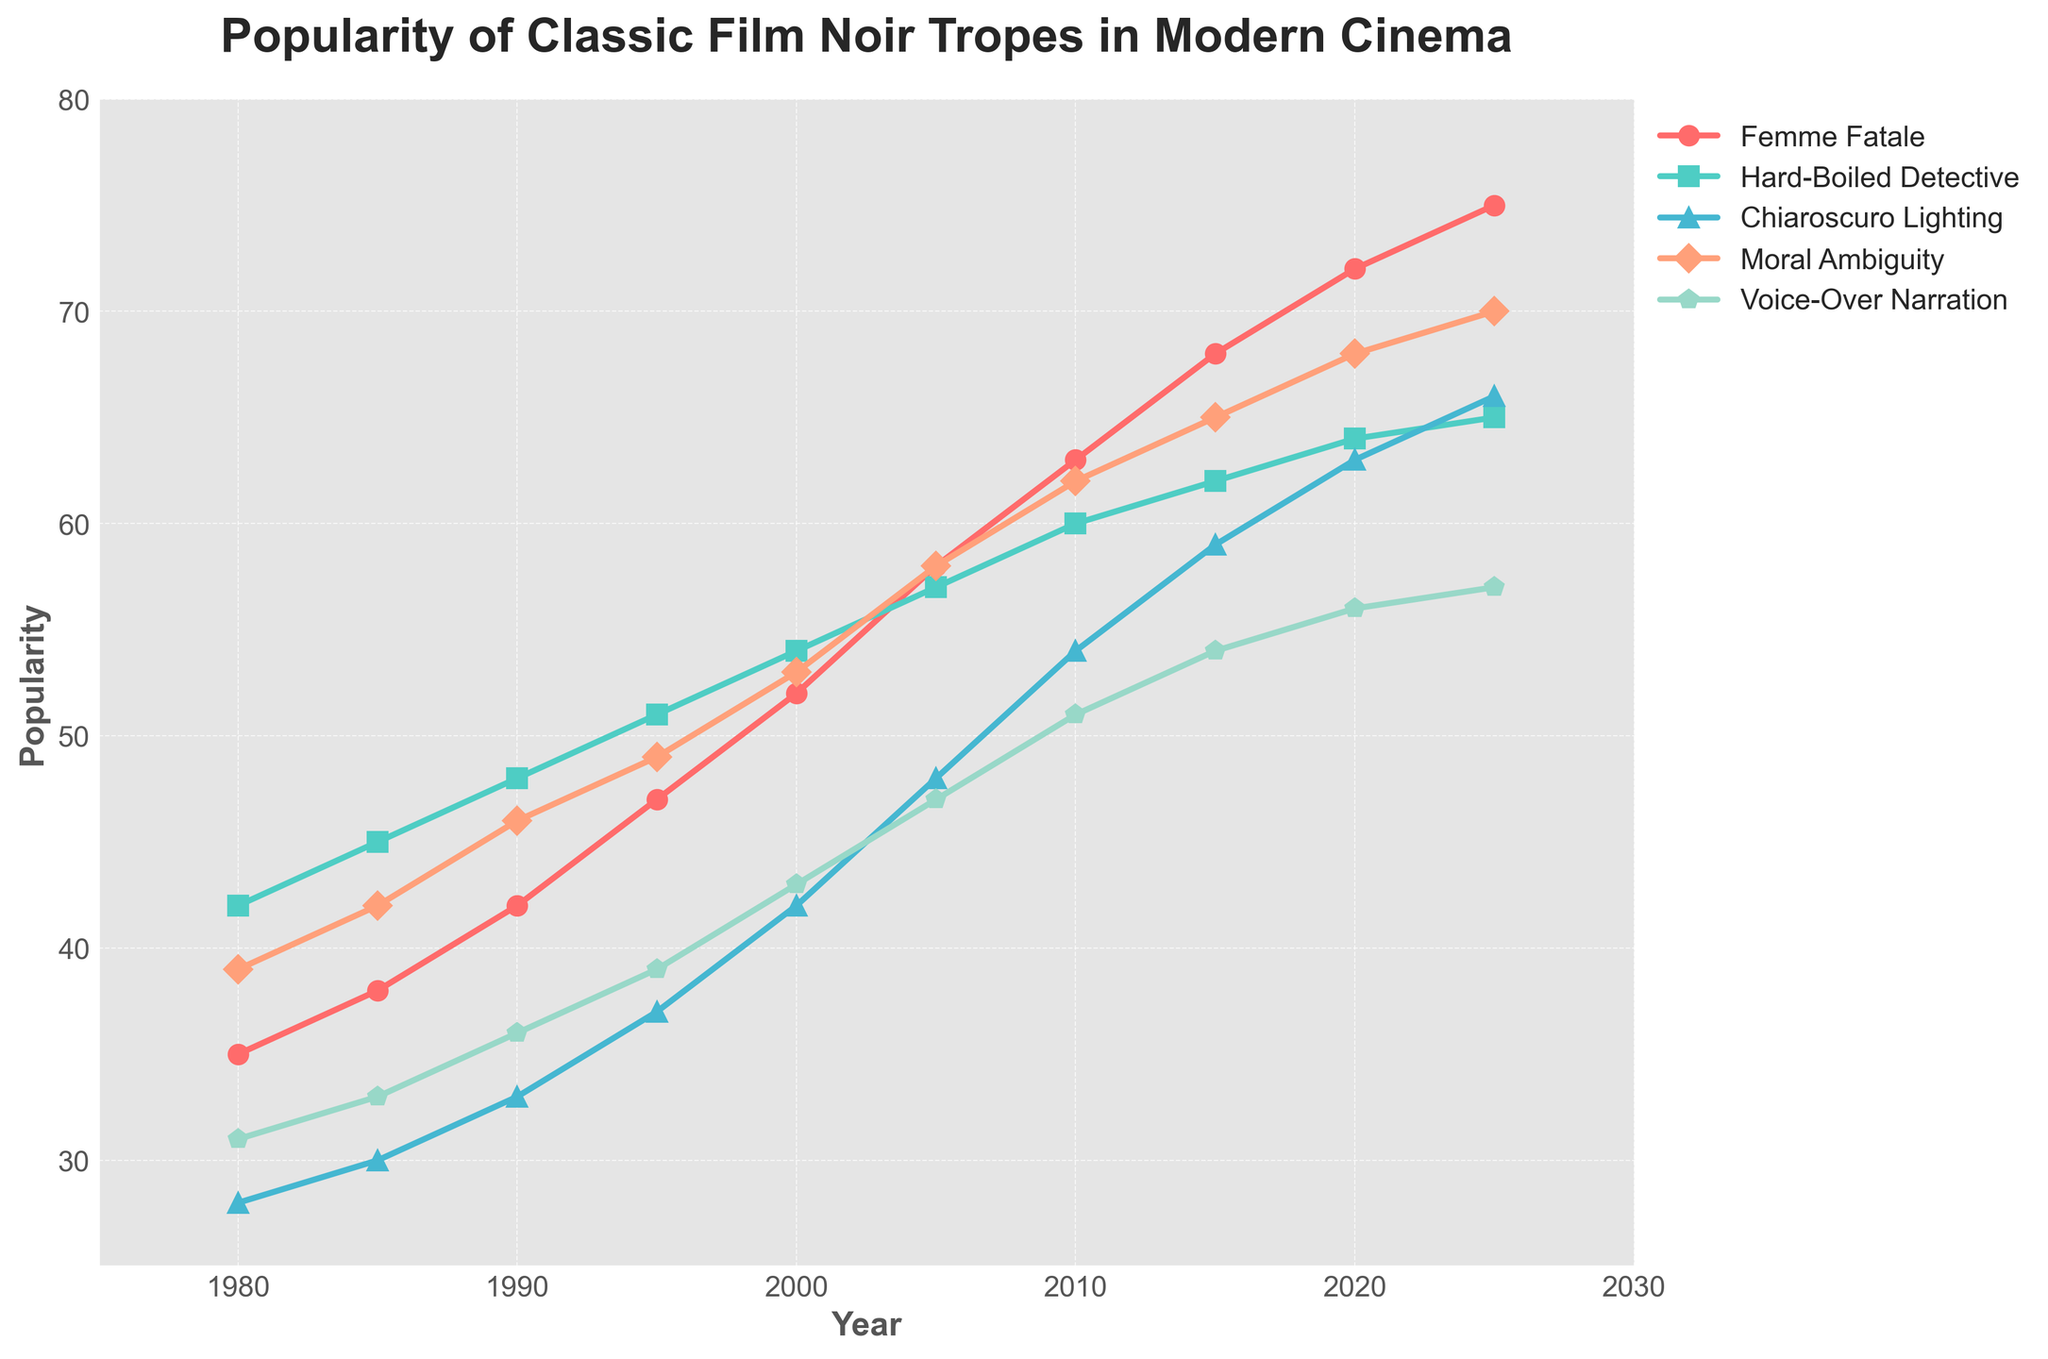What year did 'Femme Fatale' first surpass 50 in popularity? First, locate the line for 'Femme Fatale' (red) and follow it to see when it crosses the 50 mark. The plot shows it surpasses 50 in the year 2000.
Answer: 2000 Which trope reached 70 in popularity first? Look for the lines in the plot reaching 70. 'Moral Ambiguity' (orange) is the first to cross this mark in 2025.
Answer: Moral Ambiguity What is the difference in popularity between 'Hard-Boiled Detective' and 'Voice-Over Narration' in 2010? Locate the data points for 'Hard-Boiled Detective' (green) and 'Voice-Over Narration' (light blue) in 2010, which are 60 and 51 respectively. Subtract 51 from 60 to find the difference.
Answer: 9 Which trope shows the fastest increase in popularity from 1980 to 2025? Examine the slope of each line from 1980 to 2025. The steepest upward slope represents the fastest increase. 'Femme Fatale' (red) exhibits the most significant growth, going from 35 to 75.
Answer: Femme Fatale Which color represents 'Chiaroscuro Lighting'? Identify the line associated with 'Chiaroscuro Lighting' in the plot. This line is blue.
Answer: Blue In 1990, which trope was least popular, and what was its popularity score? Check the values for each trope in 1990. 'Chiaroscuro Lighting' (blue) has the lowest popularity score of 33.
Answer: Chiaroscuro Lighting, 33 What is the average popularity of 'Moral Ambiguity' over the entire time period? Sum all values of 'Moral Ambiguity' (39 + 42 + 46 + 49 + 53 + 58 + 62 + 65 + 68 + 70) = 552. Divide by the number of years (10) to get the average.
Answer: 55.2 Between 2000 and 2015, which trope had the smallest increase in popularity? Calculate the increase for each trope between 2000 and 2015. 'Voice-Over Narration' (light blue) increases from 43 to 54, which is the smallest increase (11).
Answer: Voice-Over Narration What is the total increase in popularity of 'Femme Fatale' from 1980 to 2025? Subtract the 1980 value (35) from the 2025 value (75) for 'Femme Fatale'. The total increase is 75 - 35 = 40.
Answer: 40 